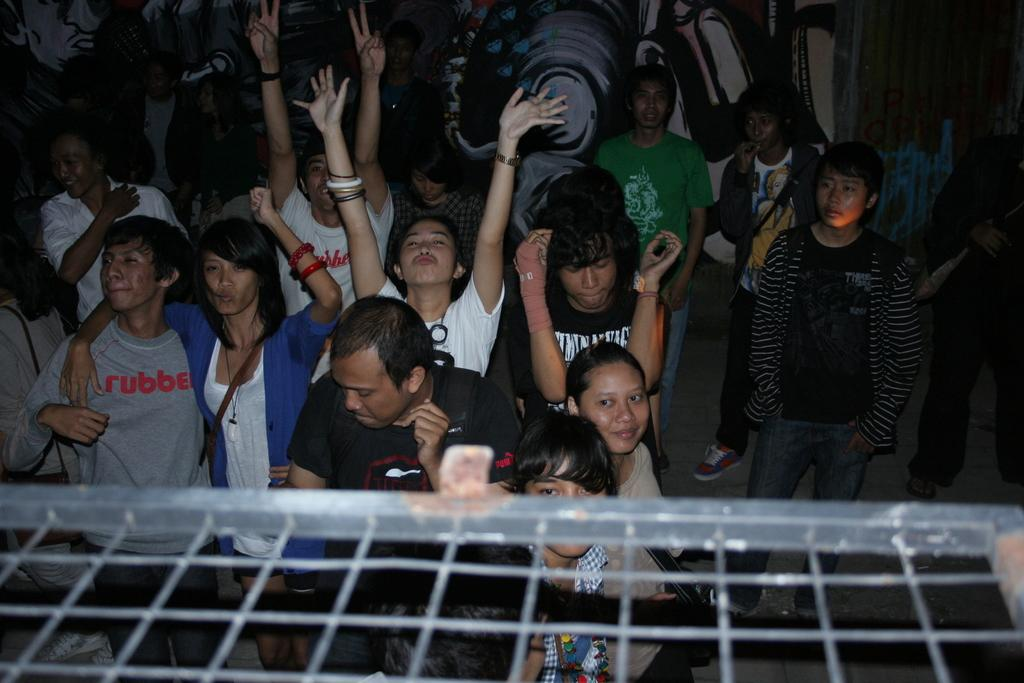What is located at the front of the image? There is a net at the front of the image. How many people can be seen in the image? Many people are present in the image. What are some people doing in the image? Some people are raising their hands. What can be seen at the back of the image? There is a painted wall at the back of the image. Can you see any eggs in the image? There are no eggs present in the image. Are there any planes flying over the people in the image? There is no mention of planes in the image, so we cannot determine if any are present. 